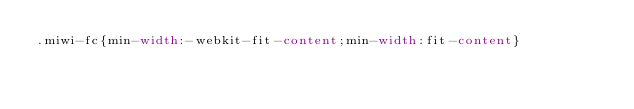Convert code to text. <code><loc_0><loc_0><loc_500><loc_500><_CSS_>.miwi-fc{min-width:-webkit-fit-content;min-width:fit-content}</code> 